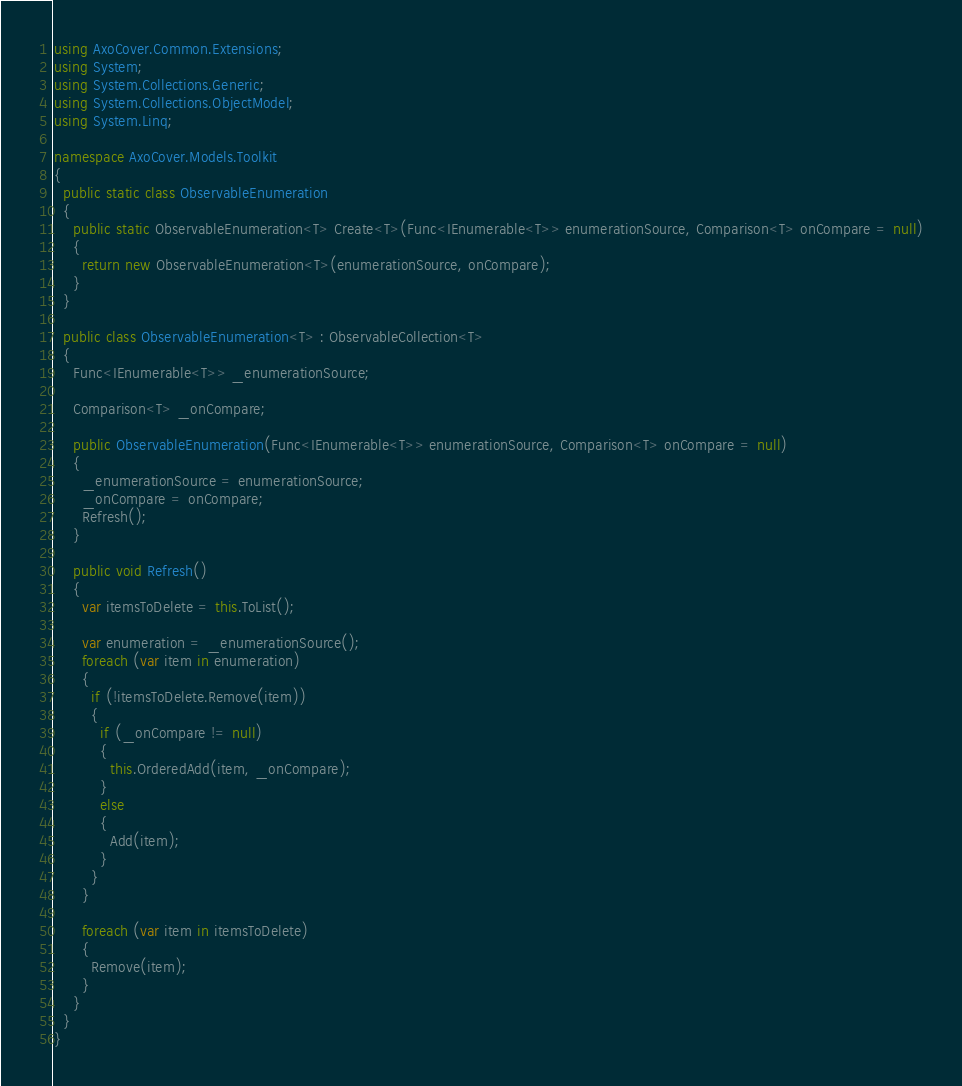Convert code to text. <code><loc_0><loc_0><loc_500><loc_500><_C#_>using AxoCover.Common.Extensions;
using System;
using System.Collections.Generic;
using System.Collections.ObjectModel;
using System.Linq;

namespace AxoCover.Models.Toolkit
{
  public static class ObservableEnumeration
  {
    public static ObservableEnumeration<T> Create<T>(Func<IEnumerable<T>> enumerationSource, Comparison<T> onCompare = null)
    {
      return new ObservableEnumeration<T>(enumerationSource, onCompare);
    }
  }

  public class ObservableEnumeration<T> : ObservableCollection<T>
  {
    Func<IEnumerable<T>> _enumerationSource;

    Comparison<T> _onCompare;

    public ObservableEnumeration(Func<IEnumerable<T>> enumerationSource, Comparison<T> onCompare = null)
    {
      _enumerationSource = enumerationSource;
      _onCompare = onCompare;
      Refresh();
    }

    public void Refresh()
    {
      var itemsToDelete = this.ToList();

      var enumeration = _enumerationSource();
      foreach (var item in enumeration)
      {
        if (!itemsToDelete.Remove(item))
        {
          if (_onCompare != null)
          {
            this.OrderedAdd(item, _onCompare);
          }
          else
          {
            Add(item);
          }
        }
      }

      foreach (var item in itemsToDelete)
      {
        Remove(item);
      }
    }
  }
}
</code> 